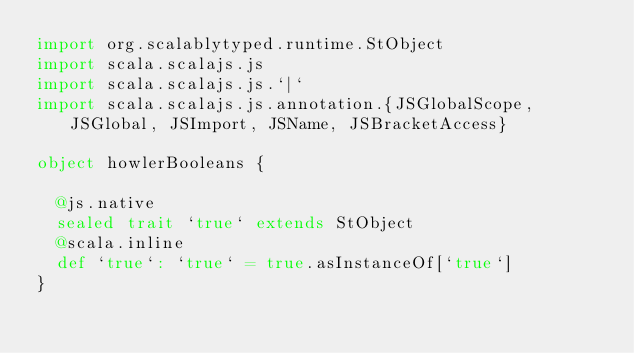<code> <loc_0><loc_0><loc_500><loc_500><_Scala_>import org.scalablytyped.runtime.StObject
import scala.scalajs.js
import scala.scalajs.js.`|`
import scala.scalajs.js.annotation.{JSGlobalScope, JSGlobal, JSImport, JSName, JSBracketAccess}

object howlerBooleans {
  
  @js.native
  sealed trait `true` extends StObject
  @scala.inline
  def `true`: `true` = true.asInstanceOf[`true`]
}
</code> 